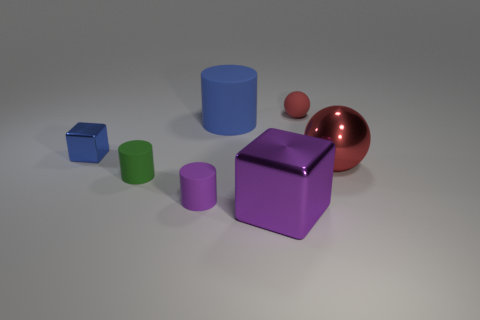Is the number of objects in front of the small ball less than the number of blue cylinders that are on the left side of the big red metal sphere?
Keep it short and to the point. No. What is the size of the red shiny thing?
Keep it short and to the point. Large. Does the big metallic object that is on the left side of the small sphere have the same color as the rubber cylinder on the left side of the tiny purple object?
Your answer should be compact. No. What number of other things are the same material as the small blue cube?
Keep it short and to the point. 2. Are any tiny gray metal balls visible?
Offer a terse response. No. Is the material of the big red thing that is right of the tiny blue shiny thing the same as the small blue object?
Offer a very short reply. Yes. What is the material of the large purple object that is the same shape as the small shiny object?
Make the answer very short. Metal. There is another ball that is the same color as the shiny ball; what is its material?
Ensure brevity in your answer.  Rubber. Is the number of big objects less than the number of purple metallic things?
Offer a very short reply. No. There is a metal object behind the metallic sphere; is it the same color as the big sphere?
Offer a terse response. No. 